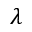Convert formula to latex. <formula><loc_0><loc_0><loc_500><loc_500>\lambda</formula> 